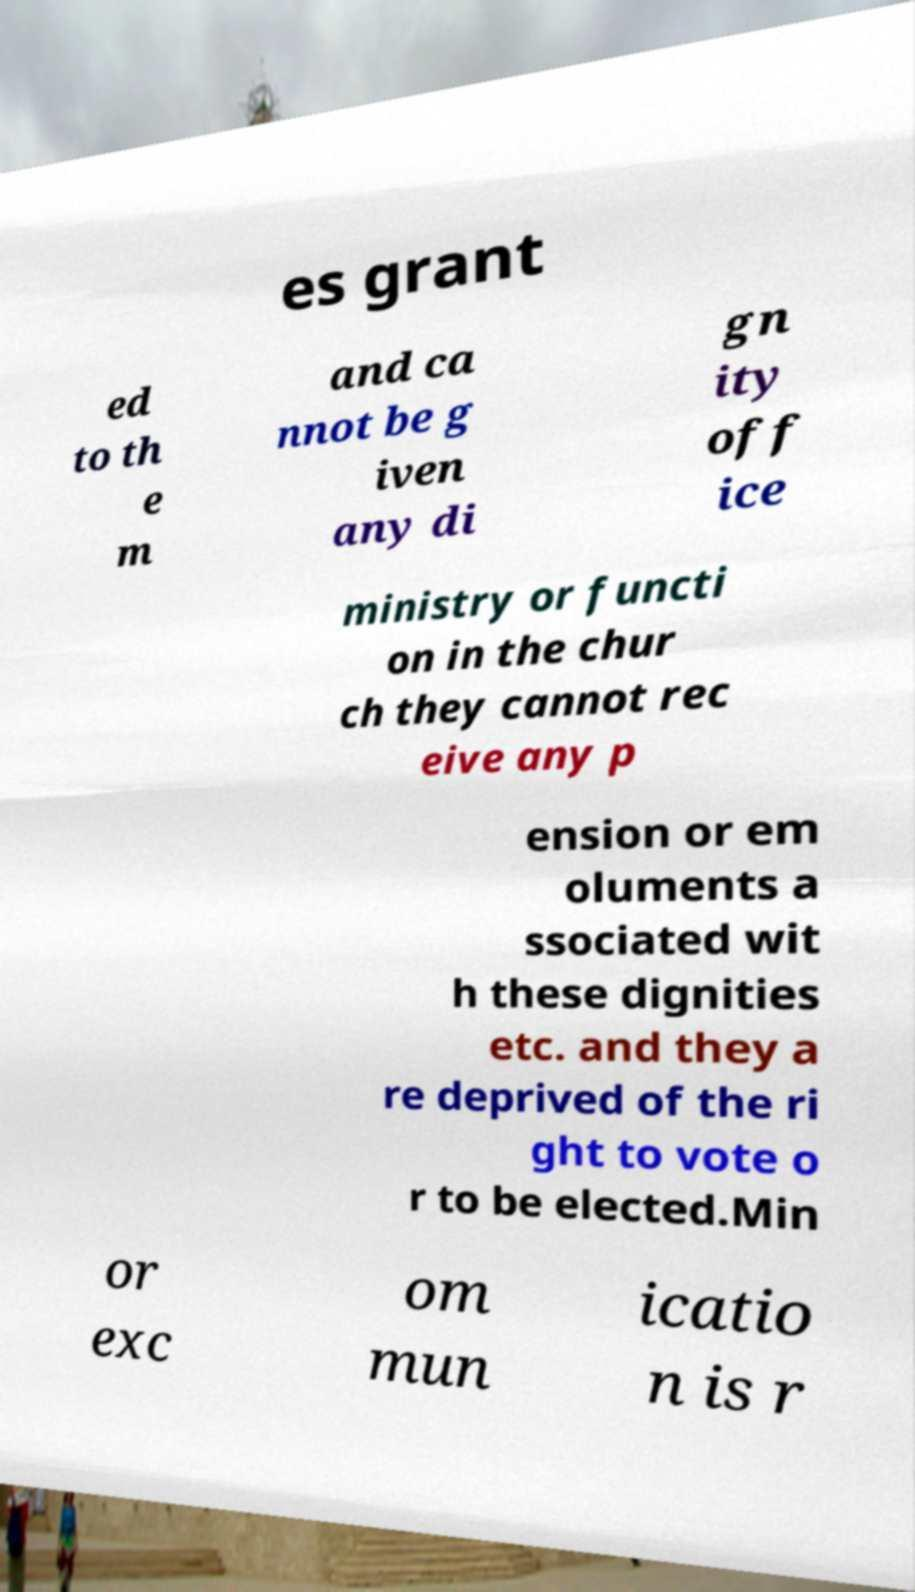Can you accurately transcribe the text from the provided image for me? es grant ed to th e m and ca nnot be g iven any di gn ity off ice ministry or functi on in the chur ch they cannot rec eive any p ension or em oluments a ssociated wit h these dignities etc. and they a re deprived of the ri ght to vote o r to be elected.Min or exc om mun icatio n is r 